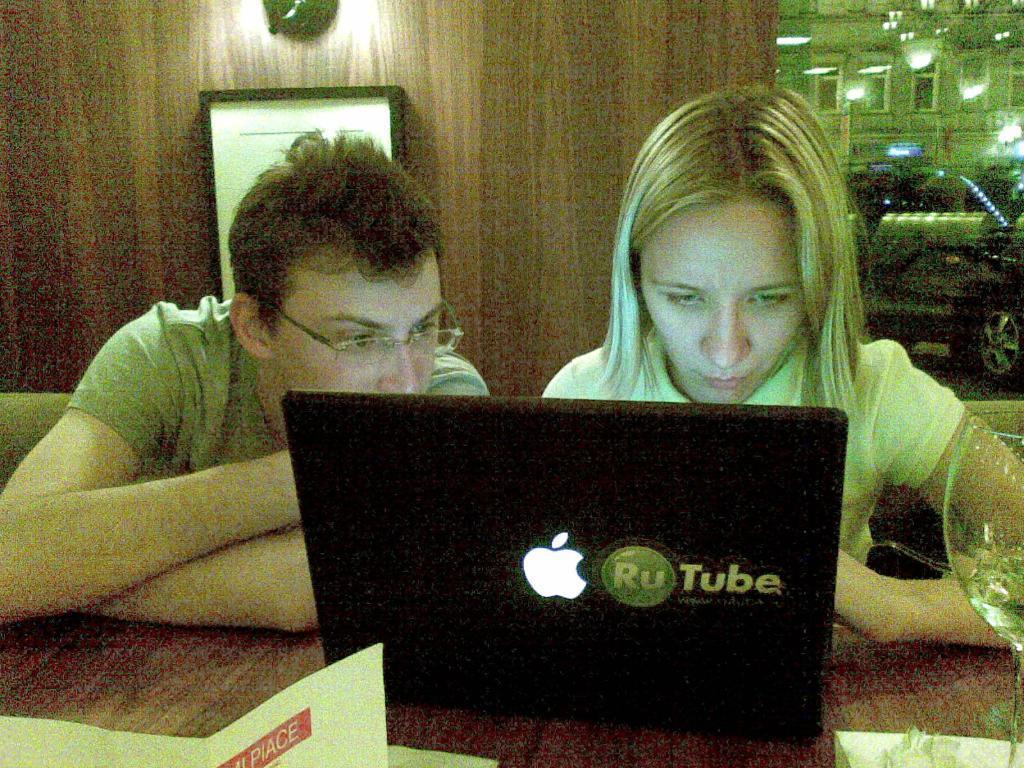Could you give a brief overview of what you see in this image? In this picture we can see a laptop, paper and a glass on a wooden table. There is a man and a woman sitting on the chair. A frame is visible on the wall. A car and some lights are visible on top. 